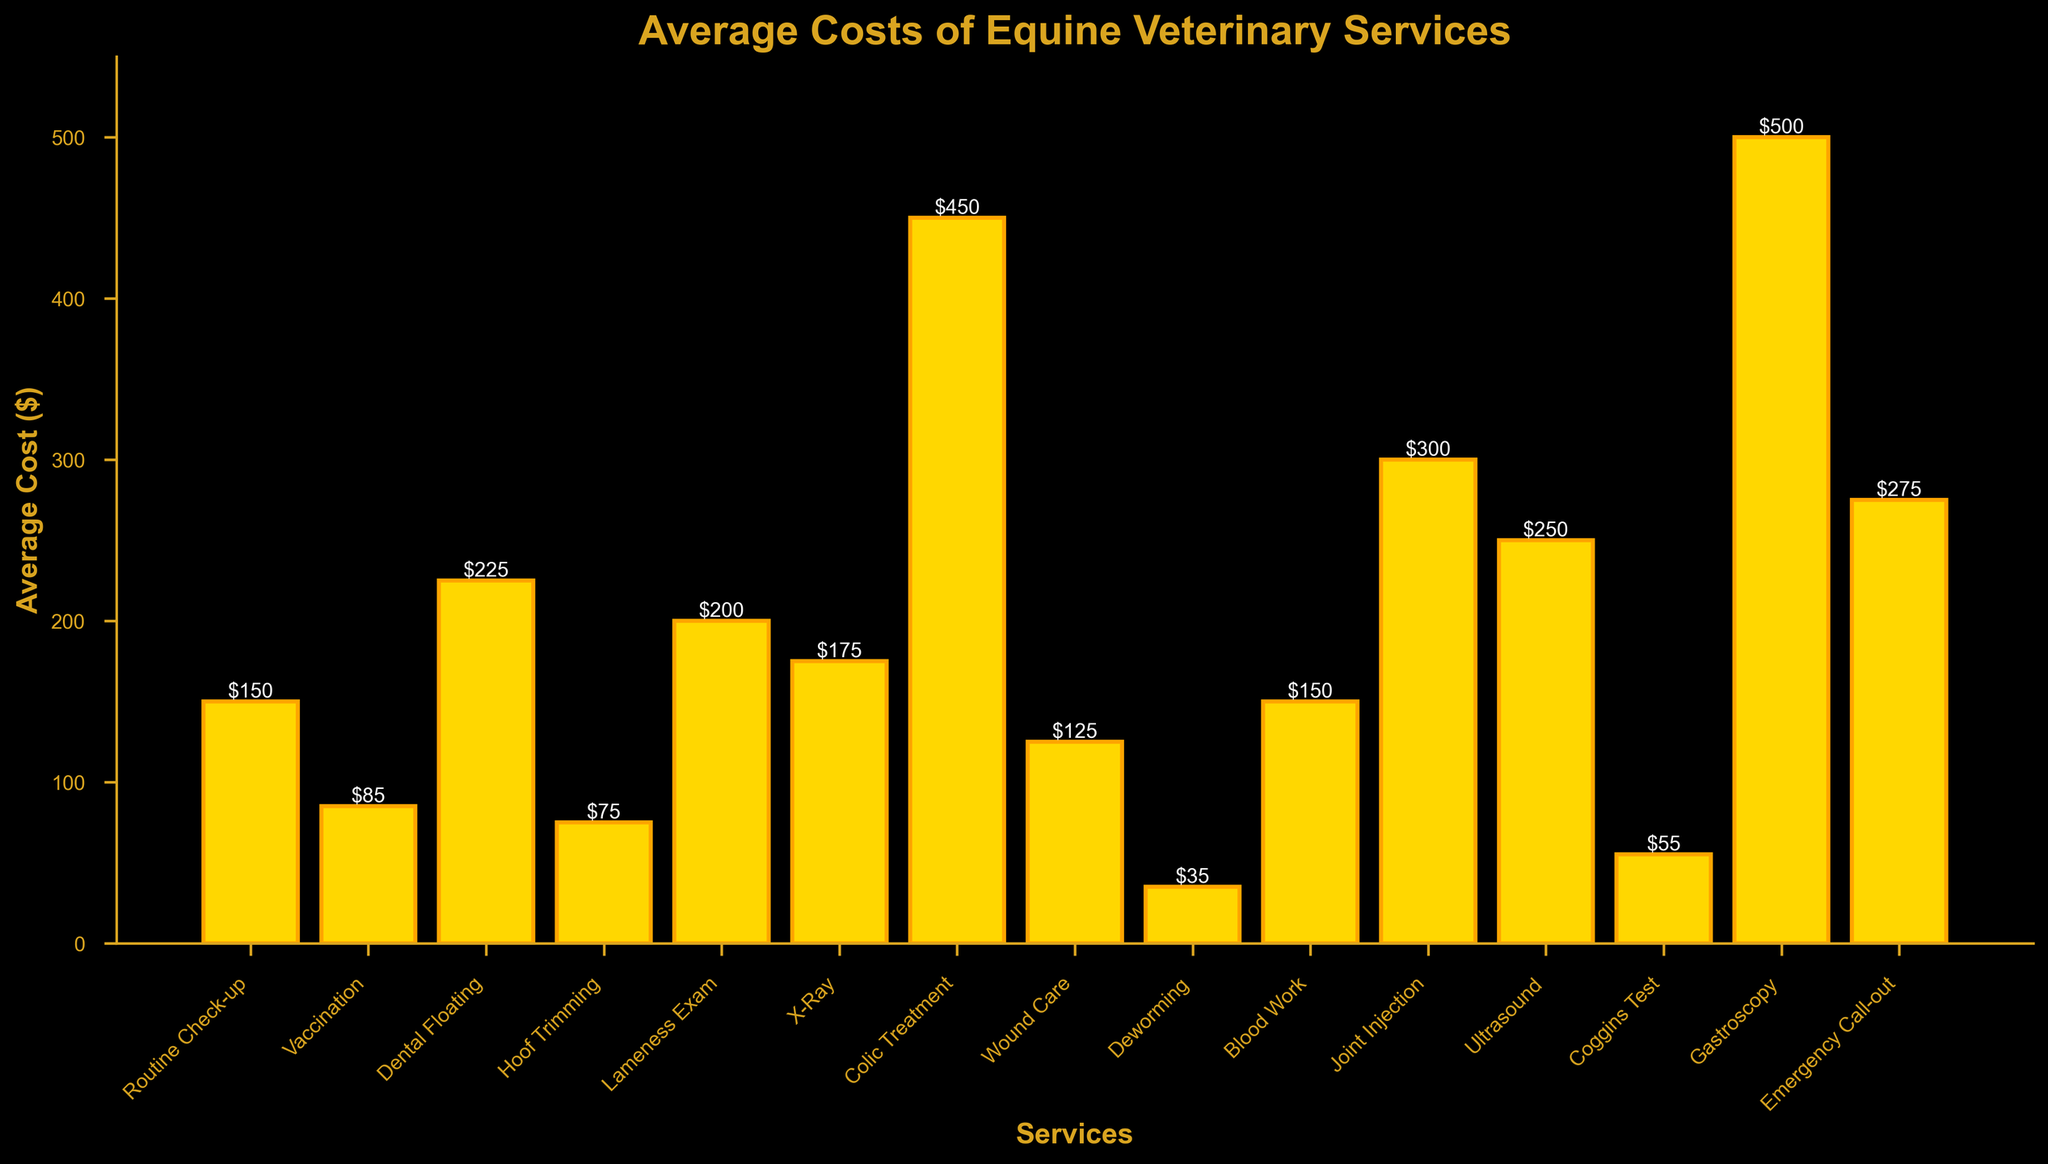Which service has the highest average cost? Look at the heights of the bars and identify the tallest one. "Gastroscopy" has the highest average cost at $500.
Answer: Gastroscopy What is the average cost difference between Ultrasound and X-Ray? Locate the bars for "Ultrasound" ($250) and "X-Ray" ($175). Subtract the average cost of X-Ray from the average cost of Ultrasound: $250 - $175 = $75.
Answer: $75 Which services cost less than $100? Identify the bars with heights less than $100. These are "Vaccination" ($85), "Hoof Trimming" ($75), "Deworming" ($35), and "Coggins Test" ($55).
Answer: Vaccination, Hoof Trimming, Deworming, Coggins Test How much more expensive is a Colic Treatment compared to a Routine Check-up? Find the bars for "Colic Treatment" ($450) and "Routine Check-up" ($150). Subtract the average cost of Routine Check-up from the cost of Colic Treatment: $450 - $150 = $300.
Answer: $300 Which service is the most expensive among Blood Work, Dental Floating, and Lameness Exam? Compare the average costs of "Blood Work" ($150), "Dental Floating" ($225), and "Lameness Exam" ($200). The most expensive is "Dental Floating" at $225.
Answer: Dental Floating What is the total average cost for Routine Check-up, Vaccination, and Hoof Trimming combined? Sum the average costs: Routine Check-up ($150) + Vaccination ($85) + Hoof Trimming ($75). The total is $150 + $85 + $75 = $310.
Answer: $310 Which service has an average cost closest to $100? Identify the bars with heights around $100. "Wound Care" has an average cost of $125, which is the closest to $100 among the services.
Answer: Wound Care Is the average cost of an Emergency Call-out higher, lower, or equal to that of an Ultrasound? Compare the bars for "Emergency Call-out" ($275) and "Ultrasound" ($250). An Emergency Call-out has a higher average cost.
Answer: Higher 